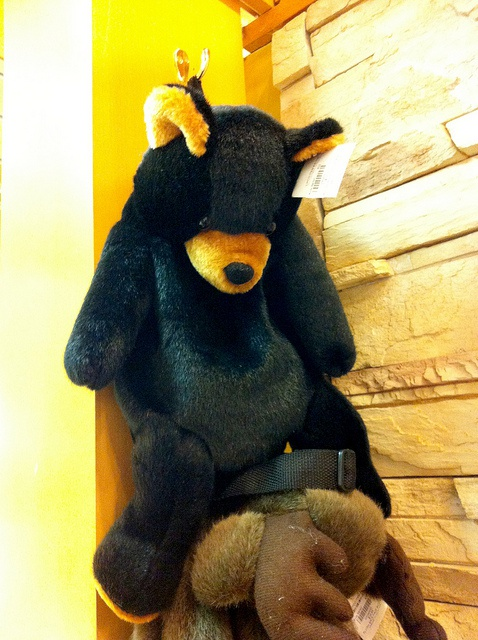Describe the objects in this image and their specific colors. I can see a teddy bear in yellow, black, maroon, orange, and red tones in this image. 